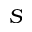Convert formula to latex. <formula><loc_0><loc_0><loc_500><loc_500>S</formula> 